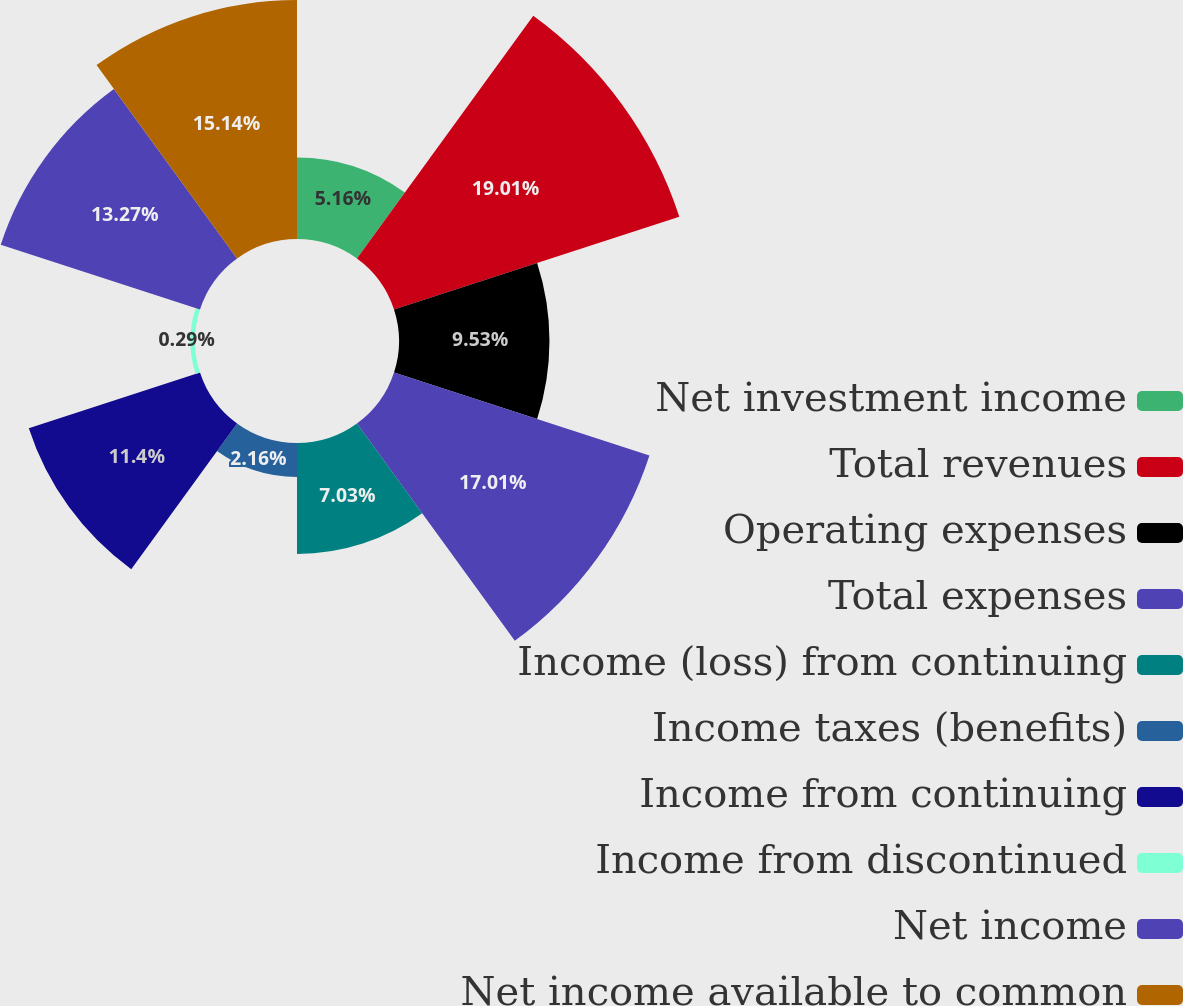Convert chart to OTSL. <chart><loc_0><loc_0><loc_500><loc_500><pie_chart><fcel>Net investment income<fcel>Total revenues<fcel>Operating expenses<fcel>Total expenses<fcel>Income (loss) from continuing<fcel>Income taxes (benefits)<fcel>Income from continuing<fcel>Income from discontinued<fcel>Net income<fcel>Net income available to common<nl><fcel>5.16%<fcel>19.0%<fcel>9.53%<fcel>17.01%<fcel>7.03%<fcel>2.16%<fcel>11.4%<fcel>0.29%<fcel>13.27%<fcel>15.14%<nl></chart> 